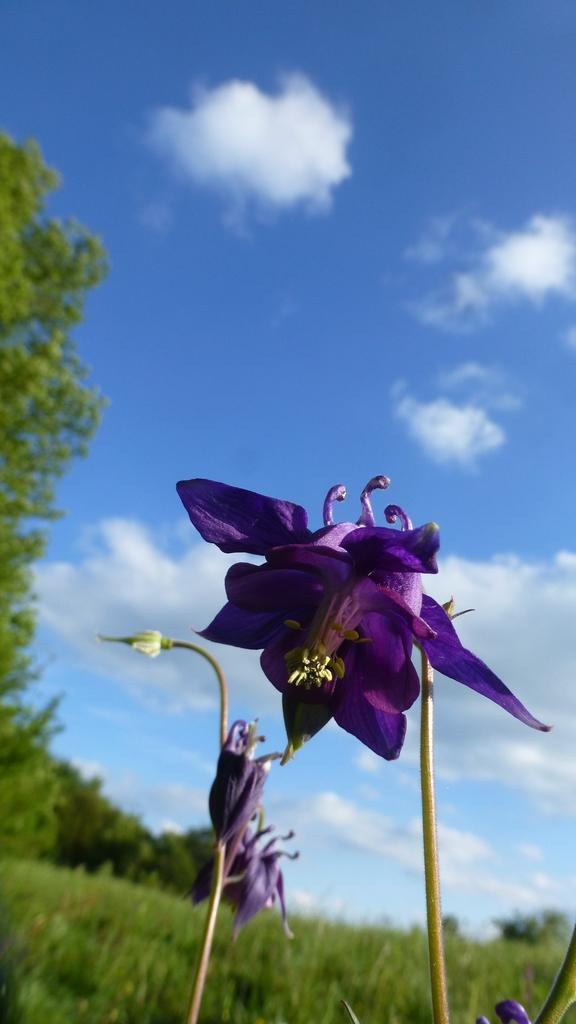Can you describe this image briefly? Here I can see two stems along with the buds and a flower. These are in violet color. In the background, I can see the grass and trees. At the top of the image I can see the sky and clouds. 